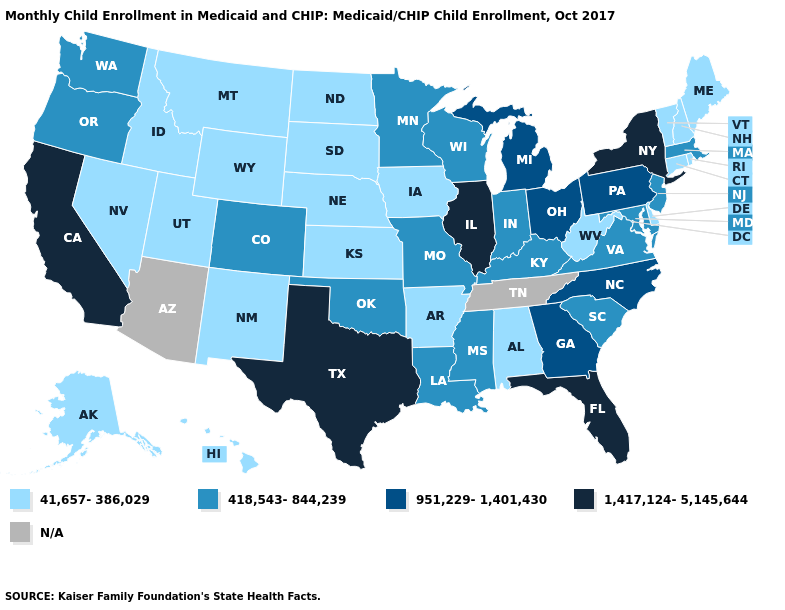What is the lowest value in states that border Utah?
Answer briefly. 41,657-386,029. Name the states that have a value in the range 41,657-386,029?
Short answer required. Alabama, Alaska, Arkansas, Connecticut, Delaware, Hawaii, Idaho, Iowa, Kansas, Maine, Montana, Nebraska, Nevada, New Hampshire, New Mexico, North Dakota, Rhode Island, South Dakota, Utah, Vermont, West Virginia, Wyoming. What is the value of Iowa?
Keep it brief. 41,657-386,029. Name the states that have a value in the range 41,657-386,029?
Short answer required. Alabama, Alaska, Arkansas, Connecticut, Delaware, Hawaii, Idaho, Iowa, Kansas, Maine, Montana, Nebraska, Nevada, New Hampshire, New Mexico, North Dakota, Rhode Island, South Dakota, Utah, Vermont, West Virginia, Wyoming. What is the highest value in the USA?
Answer briefly. 1,417,124-5,145,644. Name the states that have a value in the range 1,417,124-5,145,644?
Answer briefly. California, Florida, Illinois, New York, Texas. What is the value of Colorado?
Quick response, please. 418,543-844,239. Does the first symbol in the legend represent the smallest category?
Write a very short answer. Yes. Name the states that have a value in the range 1,417,124-5,145,644?
Concise answer only. California, Florida, Illinois, New York, Texas. Does Oklahoma have the lowest value in the South?
Be succinct. No. Which states have the lowest value in the West?
Concise answer only. Alaska, Hawaii, Idaho, Montana, Nevada, New Mexico, Utah, Wyoming. Name the states that have a value in the range 41,657-386,029?
Be succinct. Alabama, Alaska, Arkansas, Connecticut, Delaware, Hawaii, Idaho, Iowa, Kansas, Maine, Montana, Nebraska, Nevada, New Hampshire, New Mexico, North Dakota, Rhode Island, South Dakota, Utah, Vermont, West Virginia, Wyoming. What is the highest value in the West ?
Give a very brief answer. 1,417,124-5,145,644. Which states have the highest value in the USA?
Keep it brief. California, Florida, Illinois, New York, Texas. 